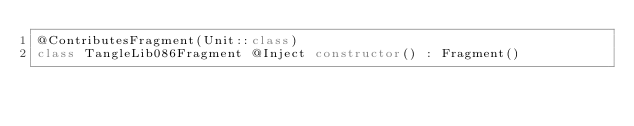Convert code to text. <code><loc_0><loc_0><loc_500><loc_500><_Kotlin_>@ContributesFragment(Unit::class)
class TangleLib086Fragment @Inject constructor() : Fragment()
</code> 